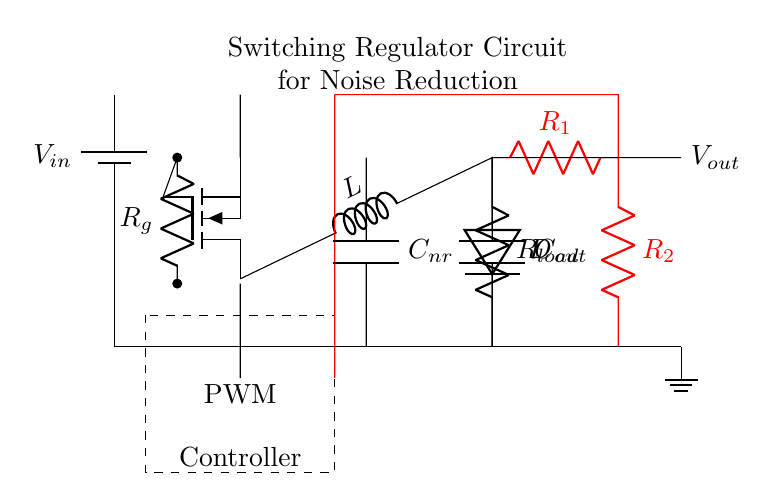What type of capacitor is used for noise reduction? The circuit shows a capacitor labeled as C nr, which stands for "noise reduction." This indicates it's specifically designed to filter out noise in the signal processing.
Answer: noise reduction What is the load resistance value in the circuit? The circuit diagram specifies a component labeled R load, indicating the resistance value connected to the output. However, the specific value is not provided in the image, only the label is.
Answer: R load What component controls the switching in the circuit? The circuit employs a component labeled as a switching transistor (shown as nigfete). This controls the on-off operation, allowing regulation of the output voltage based on feedback.
Answer: switching transistor How many resistors are part of the feedback network? There are two resistors labeled R 1 and R 2 that form a voltage divider feedback network. This network allows the controller to adjust the output voltage.
Answer: two What is the purpose of the PWM controller? The PWM controller, which is marked in the dashed rectangle, is responsible for modulating the switching pulses to the transistor, which helps in maintaining the desired output voltage level.
Answer: modulating pulses What value can be expected for the output voltage? The output voltage is labeled as V out, but the circuit does not specify the numerical value; it's dependent on the input voltage and the duty cycle of the PWM controller.
Answer: V out What connects the inductor and the diode in the circuit? The inductor labeled as L and the diode labeled as D are connected in series, where the inductor stores energy during the switching period, which is then released through the diode to the output.
Answer: inductor and diode in series 